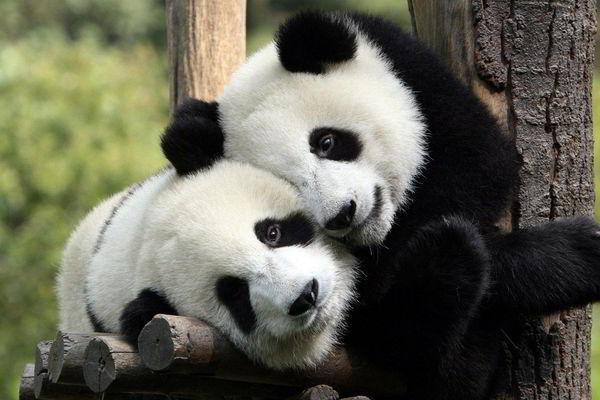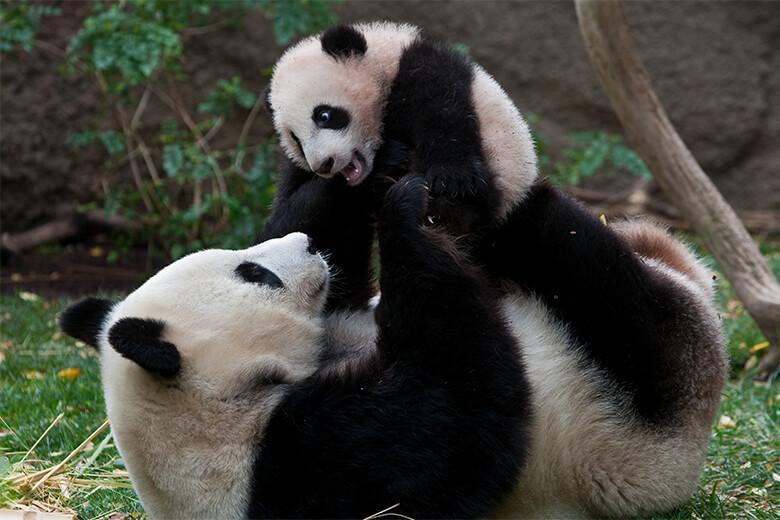The first image is the image on the left, the second image is the image on the right. Given the left and right images, does the statement "An image features a panda holding something to its mouth and chewing it." hold true? Answer yes or no. No. 